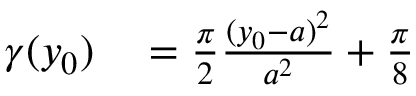<formula> <loc_0><loc_0><loc_500><loc_500>\begin{array} { r l } { \gamma ( y _ { 0 } ) } & = \frac { \pi } { 2 } \frac { ( y _ { 0 } - a ) ^ { 2 } } { a ^ { 2 } } + \frac { \pi } { 8 } } \end{array}</formula> 